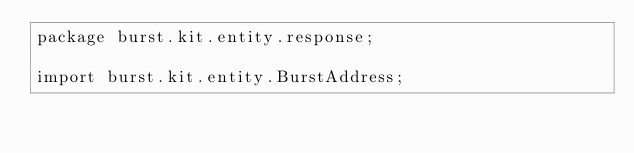Convert code to text. <code><loc_0><loc_0><loc_500><loc_500><_Java_>package burst.kit.entity.response;

import burst.kit.entity.BurstAddress;</code> 